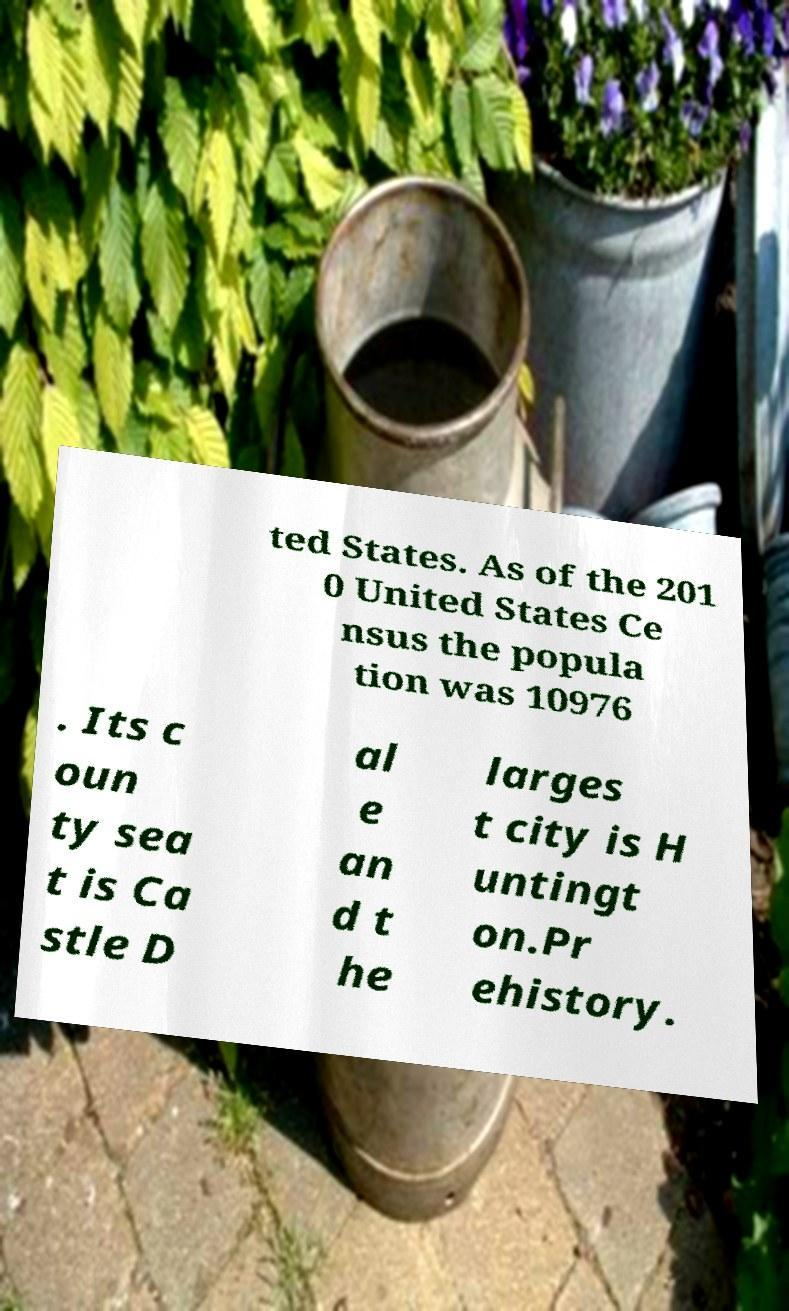There's text embedded in this image that I need extracted. Can you transcribe it verbatim? ted States. As of the 201 0 United States Ce nsus the popula tion was 10976 . Its c oun ty sea t is Ca stle D al e an d t he larges t city is H untingt on.Pr ehistory. 